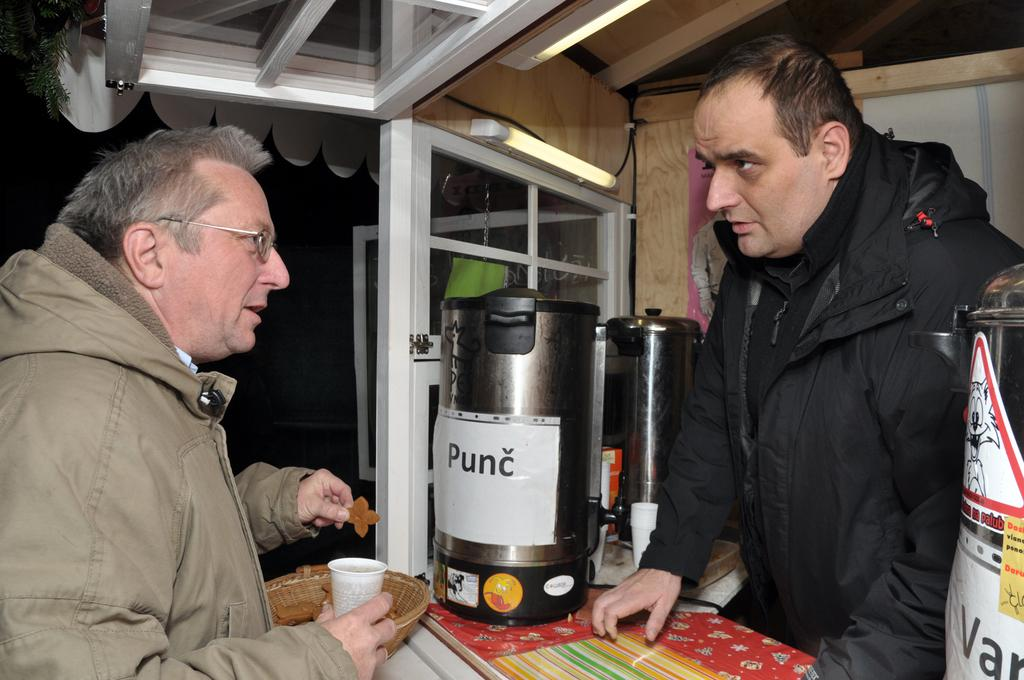Provide a one-sentence caption for the provided image. A man standing at a counter holding a cup in front of a punc container. 